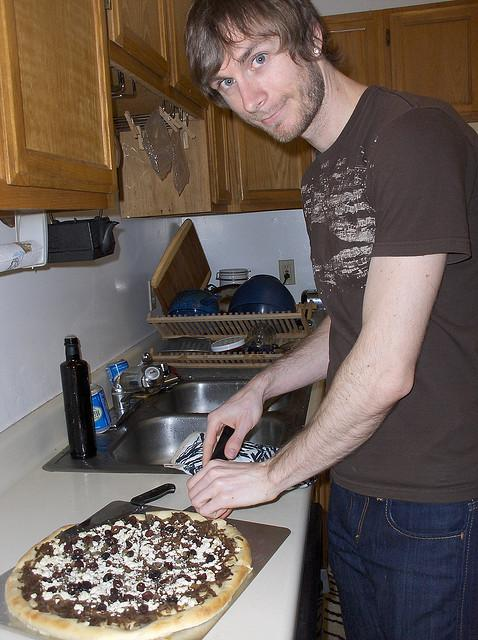What company is known for making the item that is on the counter? pizza hut 